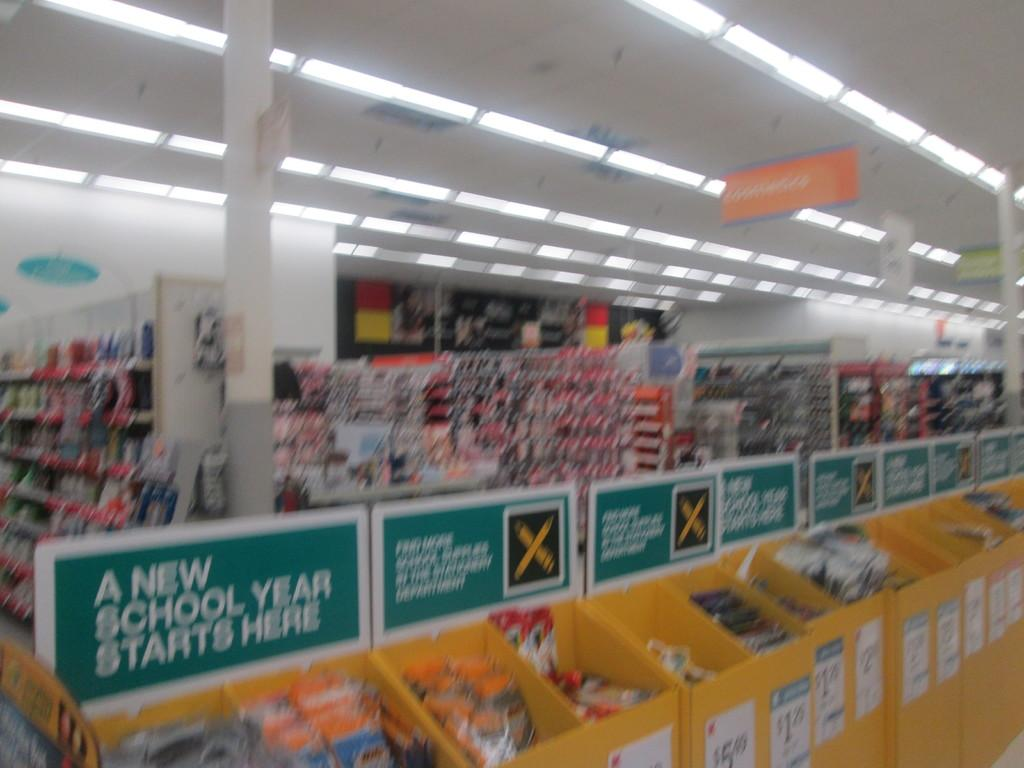Provide a one-sentence caption for the provided image. A store with bins full of school supplies and a sign stating "A New School Year Starts Here". 